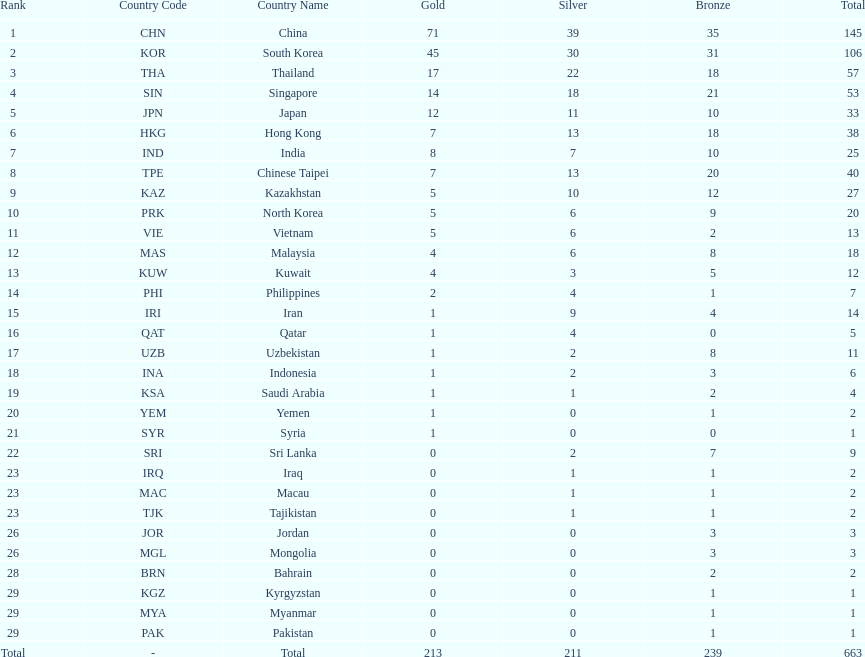What were the number of medals iran earned? 14. 